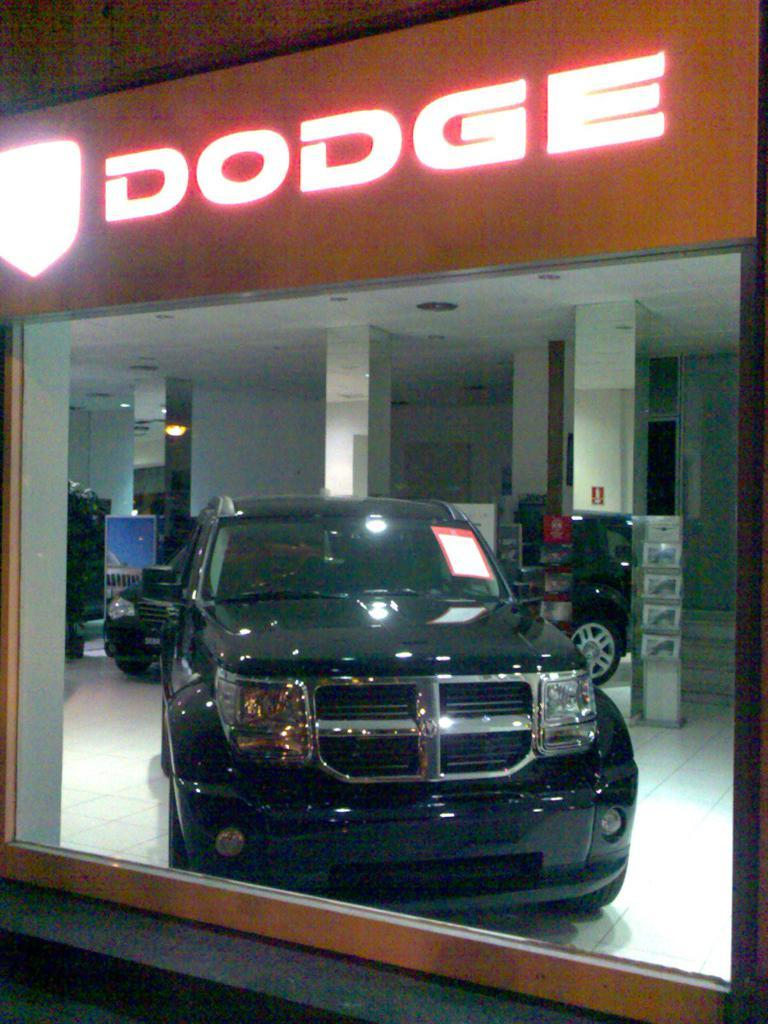What color is the car in the image? The car in the image is black. Where is the car located in the image? The car is in the center of the image. What type of discussion is taking place in the car in the image? There is no discussion taking place in the car in the image, as it is a still image and not a video or live scene. 